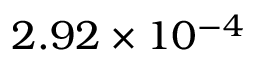Convert formula to latex. <formula><loc_0><loc_0><loc_500><loc_500>2 . 9 2 \times 1 0 ^ { - 4 }</formula> 